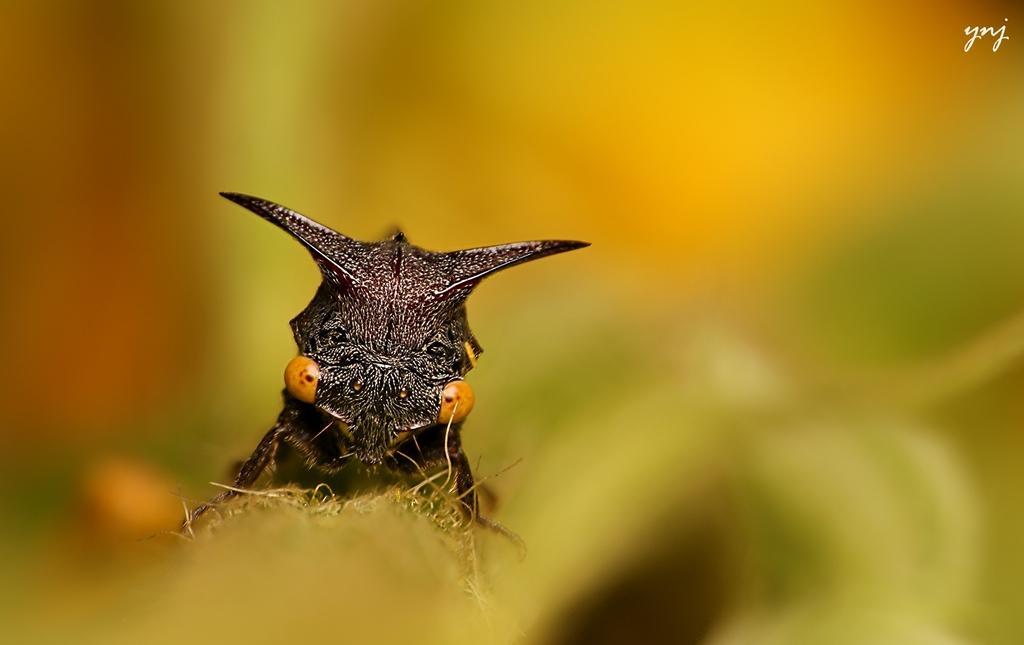How would you summarize this image in a sentence or two? In this image we can see an insect and the background is blurred. 